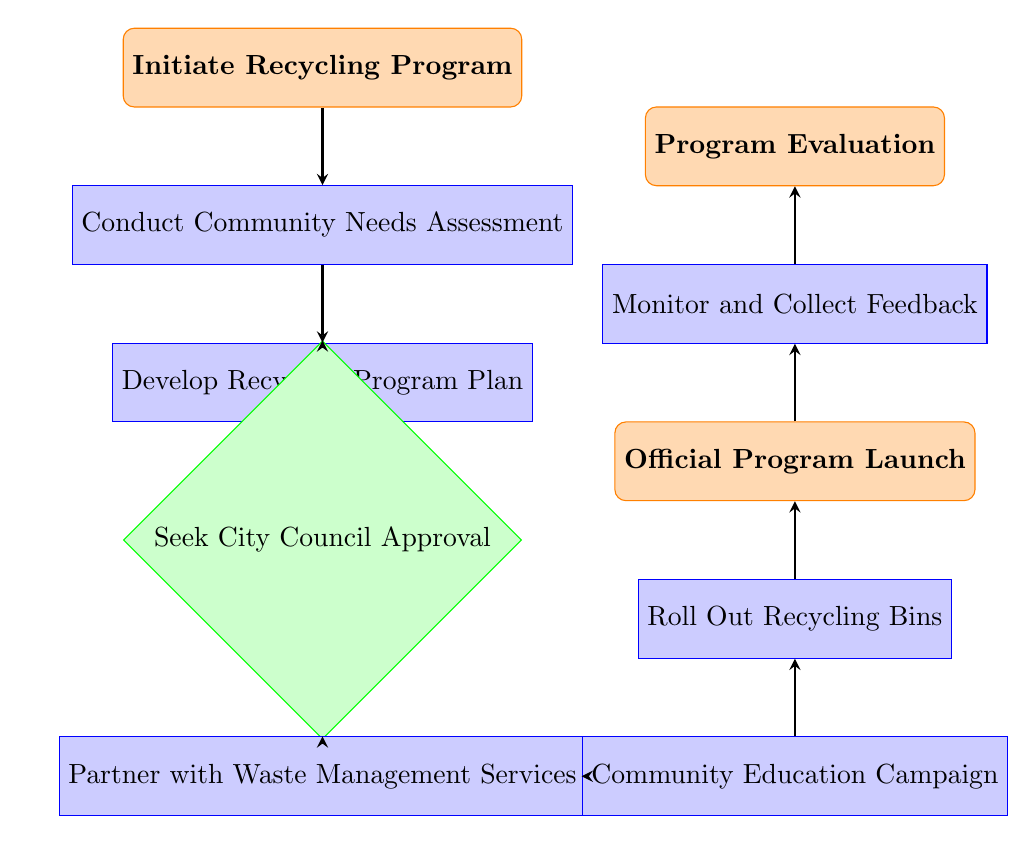What is the first step in the recycling program? The flow chart indicates that the first step is "Initiate Recycling Program", which is defined as the starting point of the process.
Answer: Initiate Recycling Program How many main processes are there in the diagram? By counting the distinct nodes labeled as processes, there are five main processes: "Conduct Community Needs Assessment", "Develop Recycling Program Plan", "Partner with Waste Management Services", "Community Education Campaign", and "Roll Out Recycling Bins".
Answer: Five What follows after the "Seek City Council Approval"? The flow chart shows that after the "Seek City Council Approval" step, the next node is "Partner with Waste Management Services". This indicates the sequence of actions in the program.
Answer: Partner with Waste Management Services Which step involves creating materials to inform residents? The step labeled "Community Education Campaign" specifically mentions creating materials to inform residents about the new recycling program, making it clear where this activity fits within the timeline.
Answer: Community Education Campaign What is the endpoint of the program timeline? The diagram explicitly states that "Program Evaluation" is the last step in the timeline, marking the conclusion of the recycling program rollout process.
Answer: Program Evaluation How does the community education campaign relate to the implementation of recycling bins? The flow chart shows that the "Community Education Campaign" occurs after partnering with waste management services and before "Roll Out Recycling Bins", indicating that education efforts directly precede implementation, thus supporting effective rollout.
Answer: Education precedes implementation What is the purpose of conducting a community needs assessment? The "Conduct Community Needs Assessment" step states that its purpose is to survey residents to understand their recycling needs and concerns, which is crucial for tailoring the program effectively.
Answer: Survey resident needs and concerns 